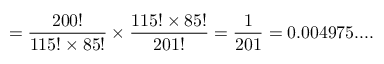Convert formula to latex. <formula><loc_0><loc_0><loc_500><loc_500>= { \frac { 2 0 0 ! } { { 1 1 5 ! } \times { 8 5 ! } } } \times { \frac { { 1 1 5 ! } \times { 8 5 ! } } { 2 0 1 ! } } = { \frac { 1 } { 2 0 1 } } = 0 . 0 0 4 9 7 5 \cdots</formula> 